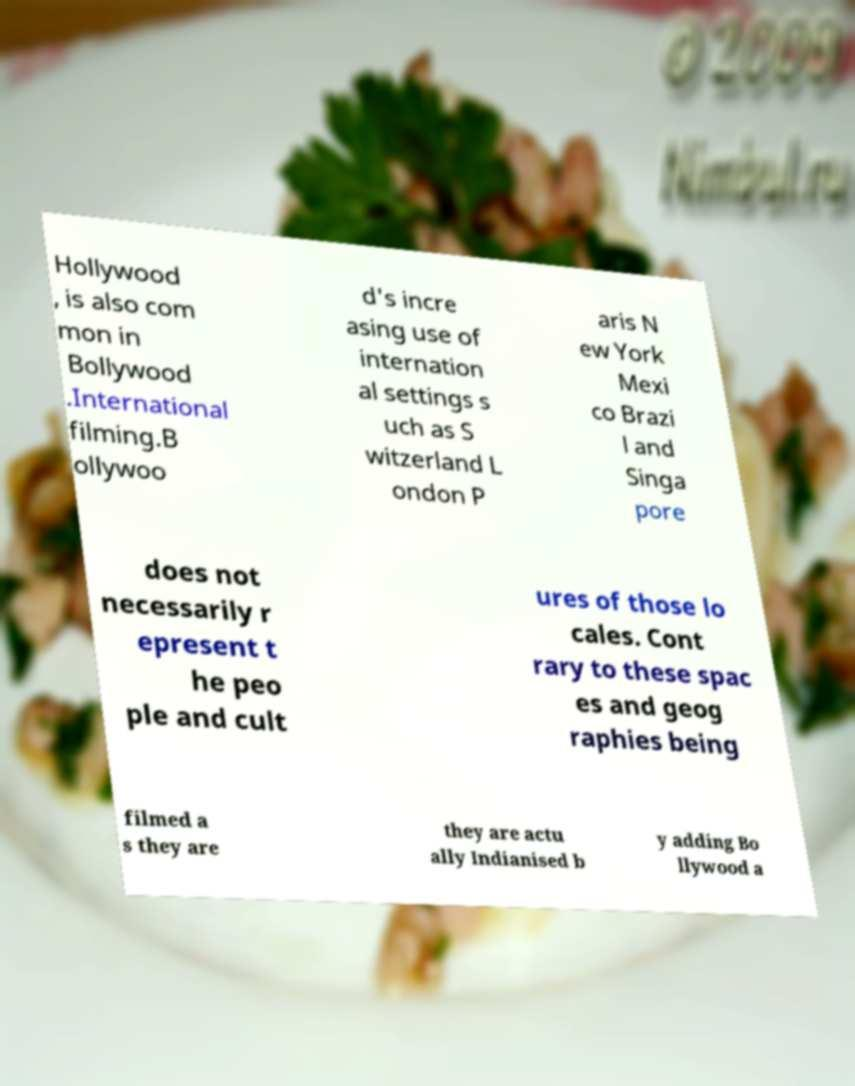What messages or text are displayed in this image? I need them in a readable, typed format. Hollywood , is also com mon in Bollywood .International filming.B ollywoo d's incre asing use of internation al settings s uch as S witzerland L ondon P aris N ew York Mexi co Brazi l and Singa pore does not necessarily r epresent t he peo ple and cult ures of those lo cales. Cont rary to these spac es and geog raphies being filmed a s they are they are actu ally Indianised b y adding Bo llywood a 